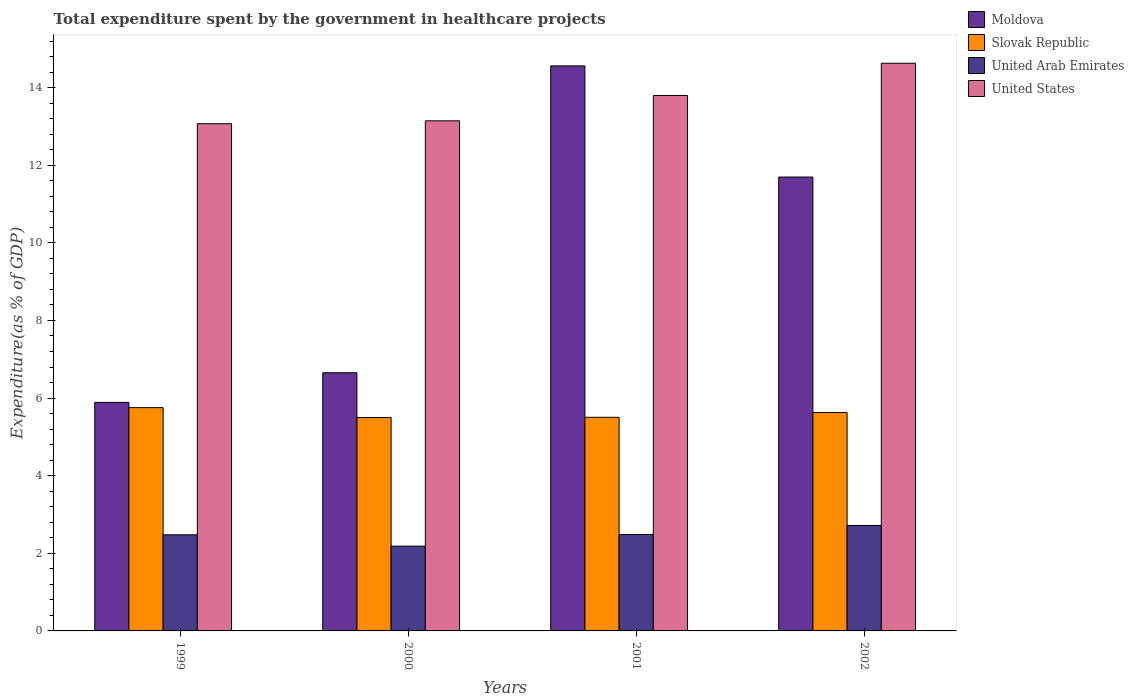How many groups of bars are there?
Your answer should be very brief. 4. How many bars are there on the 2nd tick from the left?
Your answer should be very brief. 4. How many bars are there on the 2nd tick from the right?
Ensure brevity in your answer.  4. What is the total expenditure spent by the government in healthcare projects in United Arab Emirates in 2001?
Your response must be concise. 2.48. Across all years, what is the maximum total expenditure spent by the government in healthcare projects in Moldova?
Your answer should be compact. 14.56. Across all years, what is the minimum total expenditure spent by the government in healthcare projects in United States?
Provide a succinct answer. 13.07. In which year was the total expenditure spent by the government in healthcare projects in United States maximum?
Make the answer very short. 2002. In which year was the total expenditure spent by the government in healthcare projects in Slovak Republic minimum?
Ensure brevity in your answer.  2000. What is the total total expenditure spent by the government in healthcare projects in United Arab Emirates in the graph?
Make the answer very short. 9.86. What is the difference between the total expenditure spent by the government in healthcare projects in United States in 1999 and that in 2002?
Offer a terse response. -1.56. What is the difference between the total expenditure spent by the government in healthcare projects in United States in 2000 and the total expenditure spent by the government in healthcare projects in Moldova in 2001?
Your answer should be compact. -1.42. What is the average total expenditure spent by the government in healthcare projects in United States per year?
Your response must be concise. 13.66. In the year 2002, what is the difference between the total expenditure spent by the government in healthcare projects in Moldova and total expenditure spent by the government in healthcare projects in Slovak Republic?
Provide a short and direct response. 6.07. In how many years, is the total expenditure spent by the government in healthcare projects in United States greater than 2.4 %?
Your response must be concise. 4. What is the ratio of the total expenditure spent by the government in healthcare projects in United Arab Emirates in 1999 to that in 2002?
Offer a terse response. 0.91. Is the total expenditure spent by the government in healthcare projects in Moldova in 1999 less than that in 2002?
Your answer should be very brief. Yes. Is the difference between the total expenditure spent by the government in healthcare projects in Moldova in 1999 and 2000 greater than the difference between the total expenditure spent by the government in healthcare projects in Slovak Republic in 1999 and 2000?
Give a very brief answer. No. What is the difference between the highest and the second highest total expenditure spent by the government in healthcare projects in Moldova?
Keep it short and to the point. 2.86. What is the difference between the highest and the lowest total expenditure spent by the government in healthcare projects in United Arab Emirates?
Make the answer very short. 0.53. In how many years, is the total expenditure spent by the government in healthcare projects in United States greater than the average total expenditure spent by the government in healthcare projects in United States taken over all years?
Keep it short and to the point. 2. What does the 3rd bar from the left in 2000 represents?
Provide a short and direct response. United Arab Emirates. What does the 2nd bar from the right in 2002 represents?
Offer a very short reply. United Arab Emirates. Is it the case that in every year, the sum of the total expenditure spent by the government in healthcare projects in Slovak Republic and total expenditure spent by the government in healthcare projects in United States is greater than the total expenditure spent by the government in healthcare projects in Moldova?
Ensure brevity in your answer.  Yes. Are all the bars in the graph horizontal?
Your answer should be compact. No. How many years are there in the graph?
Keep it short and to the point. 4. What is the difference between two consecutive major ticks on the Y-axis?
Your response must be concise. 2. Does the graph contain grids?
Offer a very short reply. No. Where does the legend appear in the graph?
Ensure brevity in your answer.  Top right. What is the title of the graph?
Provide a succinct answer. Total expenditure spent by the government in healthcare projects. Does "Middle East & North Africa (developing only)" appear as one of the legend labels in the graph?
Offer a very short reply. No. What is the label or title of the X-axis?
Ensure brevity in your answer.  Years. What is the label or title of the Y-axis?
Offer a terse response. Expenditure(as % of GDP). What is the Expenditure(as % of GDP) of Moldova in 1999?
Your response must be concise. 5.89. What is the Expenditure(as % of GDP) in Slovak Republic in 1999?
Keep it short and to the point. 5.75. What is the Expenditure(as % of GDP) in United Arab Emirates in 1999?
Your answer should be compact. 2.48. What is the Expenditure(as % of GDP) in United States in 1999?
Offer a very short reply. 13.07. What is the Expenditure(as % of GDP) of Moldova in 2000?
Your response must be concise. 6.65. What is the Expenditure(as % of GDP) of Slovak Republic in 2000?
Your response must be concise. 5.5. What is the Expenditure(as % of GDP) of United Arab Emirates in 2000?
Give a very brief answer. 2.19. What is the Expenditure(as % of GDP) of United States in 2000?
Make the answer very short. 13.14. What is the Expenditure(as % of GDP) of Moldova in 2001?
Offer a terse response. 14.56. What is the Expenditure(as % of GDP) in Slovak Republic in 2001?
Keep it short and to the point. 5.5. What is the Expenditure(as % of GDP) of United Arab Emirates in 2001?
Make the answer very short. 2.48. What is the Expenditure(as % of GDP) in United States in 2001?
Give a very brief answer. 13.8. What is the Expenditure(as % of GDP) of Moldova in 2002?
Keep it short and to the point. 11.7. What is the Expenditure(as % of GDP) of Slovak Republic in 2002?
Provide a short and direct response. 5.63. What is the Expenditure(as % of GDP) of United Arab Emirates in 2002?
Provide a succinct answer. 2.72. What is the Expenditure(as % of GDP) of United States in 2002?
Your answer should be very brief. 14.63. Across all years, what is the maximum Expenditure(as % of GDP) of Moldova?
Offer a terse response. 14.56. Across all years, what is the maximum Expenditure(as % of GDP) in Slovak Republic?
Give a very brief answer. 5.75. Across all years, what is the maximum Expenditure(as % of GDP) in United Arab Emirates?
Make the answer very short. 2.72. Across all years, what is the maximum Expenditure(as % of GDP) of United States?
Your answer should be compact. 14.63. Across all years, what is the minimum Expenditure(as % of GDP) of Moldova?
Offer a terse response. 5.89. Across all years, what is the minimum Expenditure(as % of GDP) in Slovak Republic?
Provide a succinct answer. 5.5. Across all years, what is the minimum Expenditure(as % of GDP) of United Arab Emirates?
Your response must be concise. 2.19. Across all years, what is the minimum Expenditure(as % of GDP) of United States?
Make the answer very short. 13.07. What is the total Expenditure(as % of GDP) of Moldova in the graph?
Your answer should be compact. 38.8. What is the total Expenditure(as % of GDP) in Slovak Republic in the graph?
Your answer should be compact. 22.39. What is the total Expenditure(as % of GDP) of United Arab Emirates in the graph?
Provide a succinct answer. 9.86. What is the total Expenditure(as % of GDP) of United States in the graph?
Provide a short and direct response. 54.64. What is the difference between the Expenditure(as % of GDP) in Moldova in 1999 and that in 2000?
Your response must be concise. -0.76. What is the difference between the Expenditure(as % of GDP) in Slovak Republic in 1999 and that in 2000?
Ensure brevity in your answer.  0.25. What is the difference between the Expenditure(as % of GDP) of United Arab Emirates in 1999 and that in 2000?
Offer a terse response. 0.29. What is the difference between the Expenditure(as % of GDP) of United States in 1999 and that in 2000?
Your answer should be very brief. -0.07. What is the difference between the Expenditure(as % of GDP) of Moldova in 1999 and that in 2001?
Provide a succinct answer. -8.67. What is the difference between the Expenditure(as % of GDP) of Slovak Republic in 1999 and that in 2001?
Offer a very short reply. 0.25. What is the difference between the Expenditure(as % of GDP) of United Arab Emirates in 1999 and that in 2001?
Provide a short and direct response. -0.01. What is the difference between the Expenditure(as % of GDP) in United States in 1999 and that in 2001?
Offer a very short reply. -0.73. What is the difference between the Expenditure(as % of GDP) in Moldova in 1999 and that in 2002?
Provide a short and direct response. -5.81. What is the difference between the Expenditure(as % of GDP) in Slovak Republic in 1999 and that in 2002?
Offer a terse response. 0.12. What is the difference between the Expenditure(as % of GDP) of United Arab Emirates in 1999 and that in 2002?
Provide a short and direct response. -0.24. What is the difference between the Expenditure(as % of GDP) in United States in 1999 and that in 2002?
Offer a very short reply. -1.56. What is the difference between the Expenditure(as % of GDP) in Moldova in 2000 and that in 2001?
Provide a short and direct response. -7.91. What is the difference between the Expenditure(as % of GDP) in Slovak Republic in 2000 and that in 2001?
Provide a succinct answer. -0.01. What is the difference between the Expenditure(as % of GDP) of United Arab Emirates in 2000 and that in 2001?
Offer a terse response. -0.3. What is the difference between the Expenditure(as % of GDP) in United States in 2000 and that in 2001?
Your response must be concise. -0.65. What is the difference between the Expenditure(as % of GDP) of Moldova in 2000 and that in 2002?
Offer a very short reply. -5.04. What is the difference between the Expenditure(as % of GDP) of Slovak Republic in 2000 and that in 2002?
Offer a very short reply. -0.13. What is the difference between the Expenditure(as % of GDP) of United Arab Emirates in 2000 and that in 2002?
Offer a terse response. -0.53. What is the difference between the Expenditure(as % of GDP) in United States in 2000 and that in 2002?
Your answer should be compact. -1.48. What is the difference between the Expenditure(as % of GDP) of Moldova in 2001 and that in 2002?
Your answer should be compact. 2.86. What is the difference between the Expenditure(as % of GDP) in Slovak Republic in 2001 and that in 2002?
Your response must be concise. -0.12. What is the difference between the Expenditure(as % of GDP) of United Arab Emirates in 2001 and that in 2002?
Ensure brevity in your answer.  -0.23. What is the difference between the Expenditure(as % of GDP) of United States in 2001 and that in 2002?
Offer a very short reply. -0.83. What is the difference between the Expenditure(as % of GDP) in Moldova in 1999 and the Expenditure(as % of GDP) in Slovak Republic in 2000?
Give a very brief answer. 0.39. What is the difference between the Expenditure(as % of GDP) in Moldova in 1999 and the Expenditure(as % of GDP) in United Arab Emirates in 2000?
Your response must be concise. 3.7. What is the difference between the Expenditure(as % of GDP) of Moldova in 1999 and the Expenditure(as % of GDP) of United States in 2000?
Your answer should be compact. -7.26. What is the difference between the Expenditure(as % of GDP) of Slovak Republic in 1999 and the Expenditure(as % of GDP) of United Arab Emirates in 2000?
Provide a short and direct response. 3.57. What is the difference between the Expenditure(as % of GDP) of Slovak Republic in 1999 and the Expenditure(as % of GDP) of United States in 2000?
Keep it short and to the point. -7.39. What is the difference between the Expenditure(as % of GDP) of United Arab Emirates in 1999 and the Expenditure(as % of GDP) of United States in 2000?
Ensure brevity in your answer.  -10.67. What is the difference between the Expenditure(as % of GDP) of Moldova in 1999 and the Expenditure(as % of GDP) of Slovak Republic in 2001?
Offer a terse response. 0.38. What is the difference between the Expenditure(as % of GDP) in Moldova in 1999 and the Expenditure(as % of GDP) in United Arab Emirates in 2001?
Make the answer very short. 3.4. What is the difference between the Expenditure(as % of GDP) in Moldova in 1999 and the Expenditure(as % of GDP) in United States in 2001?
Your response must be concise. -7.91. What is the difference between the Expenditure(as % of GDP) of Slovak Republic in 1999 and the Expenditure(as % of GDP) of United Arab Emirates in 2001?
Your answer should be very brief. 3.27. What is the difference between the Expenditure(as % of GDP) of Slovak Republic in 1999 and the Expenditure(as % of GDP) of United States in 2001?
Your answer should be compact. -8.04. What is the difference between the Expenditure(as % of GDP) of United Arab Emirates in 1999 and the Expenditure(as % of GDP) of United States in 2001?
Provide a succinct answer. -11.32. What is the difference between the Expenditure(as % of GDP) in Moldova in 1999 and the Expenditure(as % of GDP) in Slovak Republic in 2002?
Your response must be concise. 0.26. What is the difference between the Expenditure(as % of GDP) of Moldova in 1999 and the Expenditure(as % of GDP) of United Arab Emirates in 2002?
Make the answer very short. 3.17. What is the difference between the Expenditure(as % of GDP) in Moldova in 1999 and the Expenditure(as % of GDP) in United States in 2002?
Make the answer very short. -8.74. What is the difference between the Expenditure(as % of GDP) in Slovak Republic in 1999 and the Expenditure(as % of GDP) in United Arab Emirates in 2002?
Offer a terse response. 3.04. What is the difference between the Expenditure(as % of GDP) in Slovak Republic in 1999 and the Expenditure(as % of GDP) in United States in 2002?
Keep it short and to the point. -8.87. What is the difference between the Expenditure(as % of GDP) of United Arab Emirates in 1999 and the Expenditure(as % of GDP) of United States in 2002?
Provide a short and direct response. -12.15. What is the difference between the Expenditure(as % of GDP) in Moldova in 2000 and the Expenditure(as % of GDP) in Slovak Republic in 2001?
Your answer should be compact. 1.15. What is the difference between the Expenditure(as % of GDP) in Moldova in 2000 and the Expenditure(as % of GDP) in United Arab Emirates in 2001?
Make the answer very short. 4.17. What is the difference between the Expenditure(as % of GDP) in Moldova in 2000 and the Expenditure(as % of GDP) in United States in 2001?
Make the answer very short. -7.15. What is the difference between the Expenditure(as % of GDP) of Slovak Republic in 2000 and the Expenditure(as % of GDP) of United Arab Emirates in 2001?
Make the answer very short. 3.01. What is the difference between the Expenditure(as % of GDP) in Slovak Republic in 2000 and the Expenditure(as % of GDP) in United States in 2001?
Ensure brevity in your answer.  -8.3. What is the difference between the Expenditure(as % of GDP) of United Arab Emirates in 2000 and the Expenditure(as % of GDP) of United States in 2001?
Provide a succinct answer. -11.61. What is the difference between the Expenditure(as % of GDP) in Moldova in 2000 and the Expenditure(as % of GDP) in Slovak Republic in 2002?
Keep it short and to the point. 1.02. What is the difference between the Expenditure(as % of GDP) of Moldova in 2000 and the Expenditure(as % of GDP) of United Arab Emirates in 2002?
Make the answer very short. 3.94. What is the difference between the Expenditure(as % of GDP) in Moldova in 2000 and the Expenditure(as % of GDP) in United States in 2002?
Your response must be concise. -7.97. What is the difference between the Expenditure(as % of GDP) in Slovak Republic in 2000 and the Expenditure(as % of GDP) in United Arab Emirates in 2002?
Your response must be concise. 2.78. What is the difference between the Expenditure(as % of GDP) of Slovak Republic in 2000 and the Expenditure(as % of GDP) of United States in 2002?
Keep it short and to the point. -9.13. What is the difference between the Expenditure(as % of GDP) of United Arab Emirates in 2000 and the Expenditure(as % of GDP) of United States in 2002?
Your answer should be compact. -12.44. What is the difference between the Expenditure(as % of GDP) in Moldova in 2001 and the Expenditure(as % of GDP) in Slovak Republic in 2002?
Your answer should be compact. 8.93. What is the difference between the Expenditure(as % of GDP) in Moldova in 2001 and the Expenditure(as % of GDP) in United Arab Emirates in 2002?
Keep it short and to the point. 11.84. What is the difference between the Expenditure(as % of GDP) in Moldova in 2001 and the Expenditure(as % of GDP) in United States in 2002?
Your answer should be very brief. -0.07. What is the difference between the Expenditure(as % of GDP) in Slovak Republic in 2001 and the Expenditure(as % of GDP) in United Arab Emirates in 2002?
Make the answer very short. 2.79. What is the difference between the Expenditure(as % of GDP) of Slovak Republic in 2001 and the Expenditure(as % of GDP) of United States in 2002?
Keep it short and to the point. -9.12. What is the difference between the Expenditure(as % of GDP) of United Arab Emirates in 2001 and the Expenditure(as % of GDP) of United States in 2002?
Your answer should be compact. -12.14. What is the average Expenditure(as % of GDP) in Moldova per year?
Make the answer very short. 9.7. What is the average Expenditure(as % of GDP) in Slovak Republic per year?
Provide a short and direct response. 5.6. What is the average Expenditure(as % of GDP) in United Arab Emirates per year?
Your answer should be very brief. 2.47. What is the average Expenditure(as % of GDP) of United States per year?
Provide a short and direct response. 13.66. In the year 1999, what is the difference between the Expenditure(as % of GDP) in Moldova and Expenditure(as % of GDP) in Slovak Republic?
Provide a short and direct response. 0.13. In the year 1999, what is the difference between the Expenditure(as % of GDP) in Moldova and Expenditure(as % of GDP) in United Arab Emirates?
Your answer should be very brief. 3.41. In the year 1999, what is the difference between the Expenditure(as % of GDP) of Moldova and Expenditure(as % of GDP) of United States?
Give a very brief answer. -7.18. In the year 1999, what is the difference between the Expenditure(as % of GDP) in Slovak Republic and Expenditure(as % of GDP) in United Arab Emirates?
Your response must be concise. 3.28. In the year 1999, what is the difference between the Expenditure(as % of GDP) of Slovak Republic and Expenditure(as % of GDP) of United States?
Your answer should be compact. -7.32. In the year 1999, what is the difference between the Expenditure(as % of GDP) in United Arab Emirates and Expenditure(as % of GDP) in United States?
Provide a short and direct response. -10.59. In the year 2000, what is the difference between the Expenditure(as % of GDP) in Moldova and Expenditure(as % of GDP) in Slovak Republic?
Your answer should be very brief. 1.15. In the year 2000, what is the difference between the Expenditure(as % of GDP) of Moldova and Expenditure(as % of GDP) of United Arab Emirates?
Keep it short and to the point. 4.47. In the year 2000, what is the difference between the Expenditure(as % of GDP) in Moldova and Expenditure(as % of GDP) in United States?
Offer a terse response. -6.49. In the year 2000, what is the difference between the Expenditure(as % of GDP) in Slovak Republic and Expenditure(as % of GDP) in United Arab Emirates?
Give a very brief answer. 3.31. In the year 2000, what is the difference between the Expenditure(as % of GDP) of Slovak Republic and Expenditure(as % of GDP) of United States?
Provide a succinct answer. -7.65. In the year 2000, what is the difference between the Expenditure(as % of GDP) of United Arab Emirates and Expenditure(as % of GDP) of United States?
Ensure brevity in your answer.  -10.96. In the year 2001, what is the difference between the Expenditure(as % of GDP) in Moldova and Expenditure(as % of GDP) in Slovak Republic?
Offer a very short reply. 9.06. In the year 2001, what is the difference between the Expenditure(as % of GDP) in Moldova and Expenditure(as % of GDP) in United Arab Emirates?
Your answer should be compact. 12.08. In the year 2001, what is the difference between the Expenditure(as % of GDP) in Moldova and Expenditure(as % of GDP) in United States?
Your response must be concise. 0.76. In the year 2001, what is the difference between the Expenditure(as % of GDP) in Slovak Republic and Expenditure(as % of GDP) in United Arab Emirates?
Ensure brevity in your answer.  3.02. In the year 2001, what is the difference between the Expenditure(as % of GDP) in Slovak Republic and Expenditure(as % of GDP) in United States?
Provide a succinct answer. -8.29. In the year 2001, what is the difference between the Expenditure(as % of GDP) in United Arab Emirates and Expenditure(as % of GDP) in United States?
Provide a succinct answer. -11.31. In the year 2002, what is the difference between the Expenditure(as % of GDP) in Moldova and Expenditure(as % of GDP) in Slovak Republic?
Ensure brevity in your answer.  6.07. In the year 2002, what is the difference between the Expenditure(as % of GDP) in Moldova and Expenditure(as % of GDP) in United Arab Emirates?
Your answer should be compact. 8.98. In the year 2002, what is the difference between the Expenditure(as % of GDP) of Moldova and Expenditure(as % of GDP) of United States?
Provide a short and direct response. -2.93. In the year 2002, what is the difference between the Expenditure(as % of GDP) of Slovak Republic and Expenditure(as % of GDP) of United Arab Emirates?
Provide a short and direct response. 2.91. In the year 2002, what is the difference between the Expenditure(as % of GDP) in Slovak Republic and Expenditure(as % of GDP) in United States?
Make the answer very short. -9. In the year 2002, what is the difference between the Expenditure(as % of GDP) of United Arab Emirates and Expenditure(as % of GDP) of United States?
Your answer should be very brief. -11.91. What is the ratio of the Expenditure(as % of GDP) of Moldova in 1999 to that in 2000?
Offer a terse response. 0.89. What is the ratio of the Expenditure(as % of GDP) of Slovak Republic in 1999 to that in 2000?
Provide a short and direct response. 1.05. What is the ratio of the Expenditure(as % of GDP) in United Arab Emirates in 1999 to that in 2000?
Provide a succinct answer. 1.13. What is the ratio of the Expenditure(as % of GDP) in Moldova in 1999 to that in 2001?
Provide a short and direct response. 0.4. What is the ratio of the Expenditure(as % of GDP) of Slovak Republic in 1999 to that in 2001?
Make the answer very short. 1.05. What is the ratio of the Expenditure(as % of GDP) of United States in 1999 to that in 2001?
Keep it short and to the point. 0.95. What is the ratio of the Expenditure(as % of GDP) in Moldova in 1999 to that in 2002?
Keep it short and to the point. 0.5. What is the ratio of the Expenditure(as % of GDP) of Slovak Republic in 1999 to that in 2002?
Make the answer very short. 1.02. What is the ratio of the Expenditure(as % of GDP) in United Arab Emirates in 1999 to that in 2002?
Your answer should be compact. 0.91. What is the ratio of the Expenditure(as % of GDP) of United States in 1999 to that in 2002?
Offer a terse response. 0.89. What is the ratio of the Expenditure(as % of GDP) in Moldova in 2000 to that in 2001?
Keep it short and to the point. 0.46. What is the ratio of the Expenditure(as % of GDP) of Slovak Republic in 2000 to that in 2001?
Make the answer very short. 1. What is the ratio of the Expenditure(as % of GDP) of United Arab Emirates in 2000 to that in 2001?
Your answer should be compact. 0.88. What is the ratio of the Expenditure(as % of GDP) in United States in 2000 to that in 2001?
Your response must be concise. 0.95. What is the ratio of the Expenditure(as % of GDP) of Moldova in 2000 to that in 2002?
Provide a succinct answer. 0.57. What is the ratio of the Expenditure(as % of GDP) of Slovak Republic in 2000 to that in 2002?
Give a very brief answer. 0.98. What is the ratio of the Expenditure(as % of GDP) in United Arab Emirates in 2000 to that in 2002?
Offer a very short reply. 0.8. What is the ratio of the Expenditure(as % of GDP) of United States in 2000 to that in 2002?
Keep it short and to the point. 0.9. What is the ratio of the Expenditure(as % of GDP) of Moldova in 2001 to that in 2002?
Your response must be concise. 1.24. What is the ratio of the Expenditure(as % of GDP) in Slovak Republic in 2001 to that in 2002?
Keep it short and to the point. 0.98. What is the ratio of the Expenditure(as % of GDP) of United Arab Emirates in 2001 to that in 2002?
Offer a terse response. 0.91. What is the ratio of the Expenditure(as % of GDP) in United States in 2001 to that in 2002?
Offer a very short reply. 0.94. What is the difference between the highest and the second highest Expenditure(as % of GDP) in Moldova?
Your answer should be compact. 2.86. What is the difference between the highest and the second highest Expenditure(as % of GDP) in Slovak Republic?
Ensure brevity in your answer.  0.12. What is the difference between the highest and the second highest Expenditure(as % of GDP) of United Arab Emirates?
Offer a terse response. 0.23. What is the difference between the highest and the second highest Expenditure(as % of GDP) in United States?
Your answer should be very brief. 0.83. What is the difference between the highest and the lowest Expenditure(as % of GDP) of Moldova?
Provide a short and direct response. 8.67. What is the difference between the highest and the lowest Expenditure(as % of GDP) in Slovak Republic?
Offer a very short reply. 0.25. What is the difference between the highest and the lowest Expenditure(as % of GDP) in United Arab Emirates?
Make the answer very short. 0.53. What is the difference between the highest and the lowest Expenditure(as % of GDP) of United States?
Offer a very short reply. 1.56. 